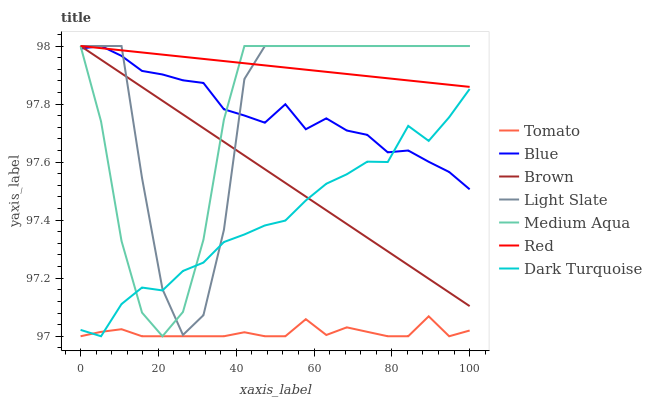Does Tomato have the minimum area under the curve?
Answer yes or no. Yes. Does Red have the maximum area under the curve?
Answer yes or no. Yes. Does Blue have the minimum area under the curve?
Answer yes or no. No. Does Blue have the maximum area under the curve?
Answer yes or no. No. Is Red the smoothest?
Answer yes or no. Yes. Is Light Slate the roughest?
Answer yes or no. Yes. Is Blue the smoothest?
Answer yes or no. No. Is Blue the roughest?
Answer yes or no. No. Does Tomato have the lowest value?
Answer yes or no. Yes. Does Blue have the lowest value?
Answer yes or no. No. Does Red have the highest value?
Answer yes or no. Yes. Does Dark Turquoise have the highest value?
Answer yes or no. No. Is Tomato less than Blue?
Answer yes or no. Yes. Is Red greater than Dark Turquoise?
Answer yes or no. Yes. Does Medium Aqua intersect Light Slate?
Answer yes or no. Yes. Is Medium Aqua less than Light Slate?
Answer yes or no. No. Is Medium Aqua greater than Light Slate?
Answer yes or no. No. Does Tomato intersect Blue?
Answer yes or no. No. 